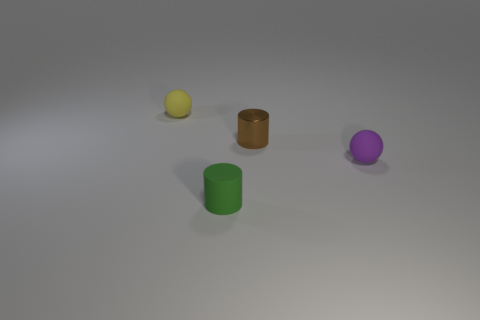Add 2 small purple things. How many objects exist? 6 Add 3 small brown objects. How many small brown objects are left? 4 Add 4 tiny cyan cylinders. How many tiny cyan cylinders exist? 4 Subtract 0 red cubes. How many objects are left? 4 Subtract all small objects. Subtract all purple metallic cylinders. How many objects are left? 0 